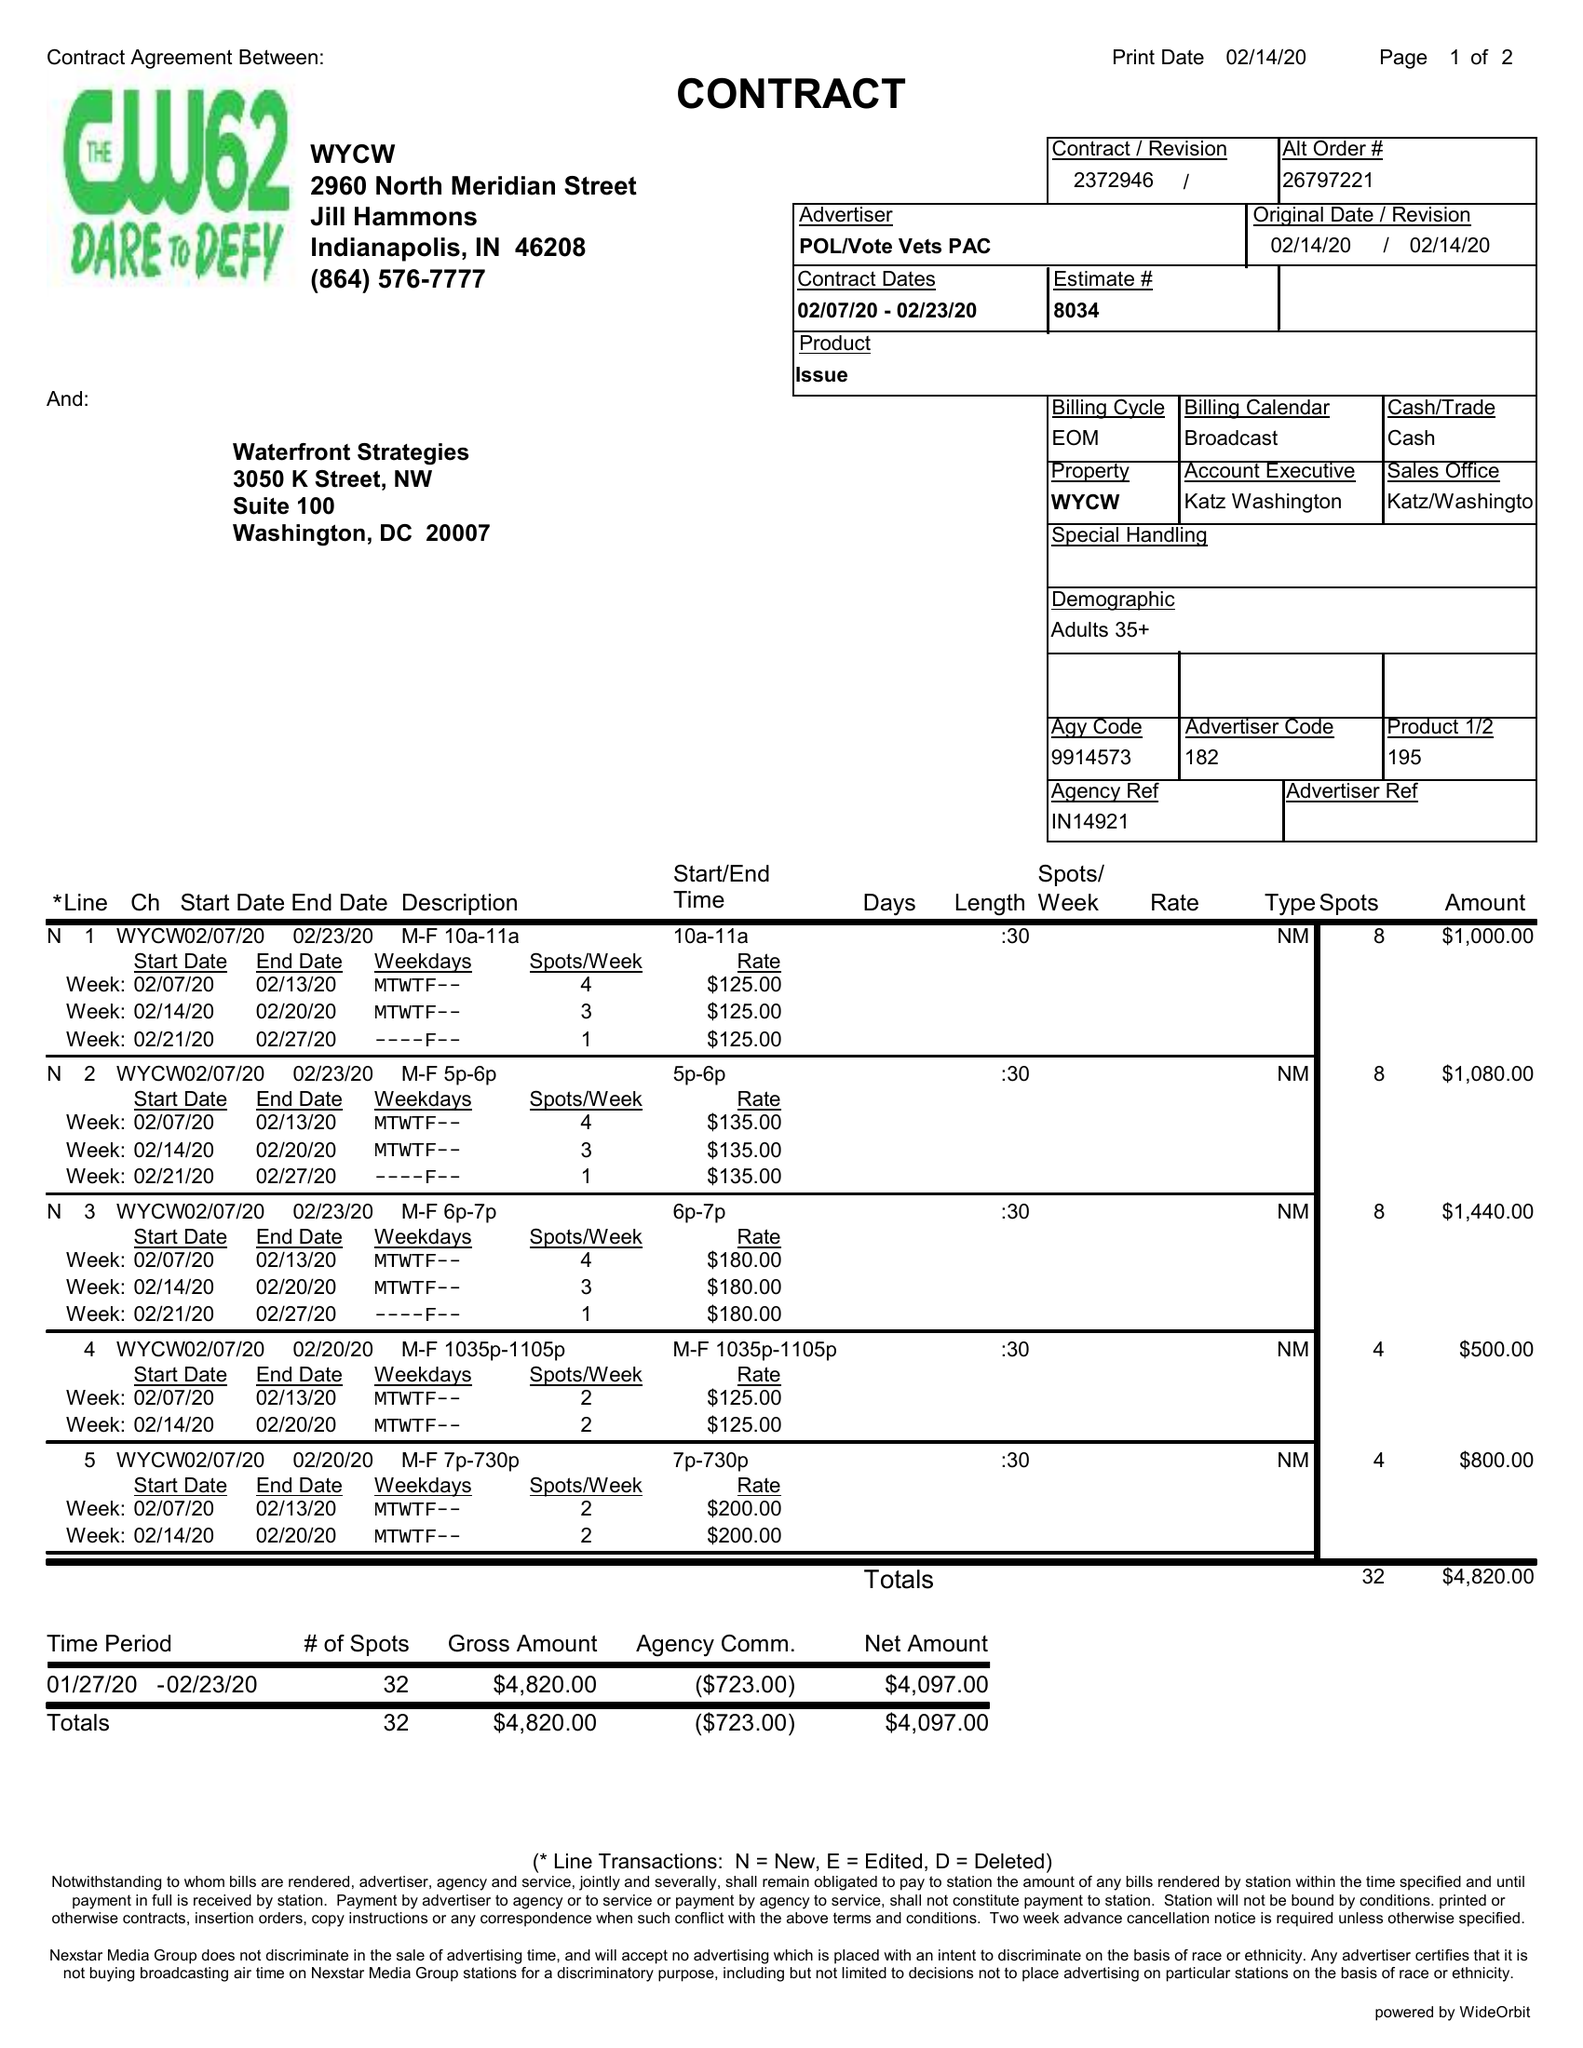What is the value for the contract_num?
Answer the question using a single word or phrase. 2372946 